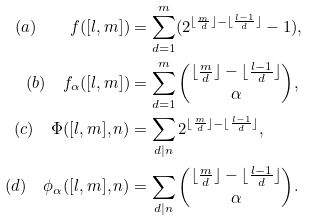<formula> <loc_0><loc_0><loc_500><loc_500>( a ) \quad f ( [ l , m ] ) & = \sum _ { d = 1 } ^ { m } ( 2 ^ { \lfloor \frac { m } { d } \rfloor - \lfloor \frac { l - 1 } { d } \rfloor } - 1 ) , \\ ( b ) \quad f _ { \alpha } ( [ l , m ] ) & = \sum _ { d = 1 } ^ { m } \binom { \lfloor \frac { m } { d } \rfloor - \lfloor \frac { l - 1 } { d } \rfloor } { \alpha } , \\ ( c ) \quad \Phi ( [ l , m ] , n ) & = \sum _ { d | n } 2 ^ { \lfloor \frac { m } { d } \rfloor - \lfloor \frac { l - 1 } { d } \rfloor } , \\ ( d ) \quad \phi _ { \alpha } ( [ l , m ] , n ) & = \sum _ { d | n } \binom { \lfloor \frac { m } { d } \rfloor - \lfloor \frac { l - 1 } { d } \rfloor } { \alpha } .</formula> 